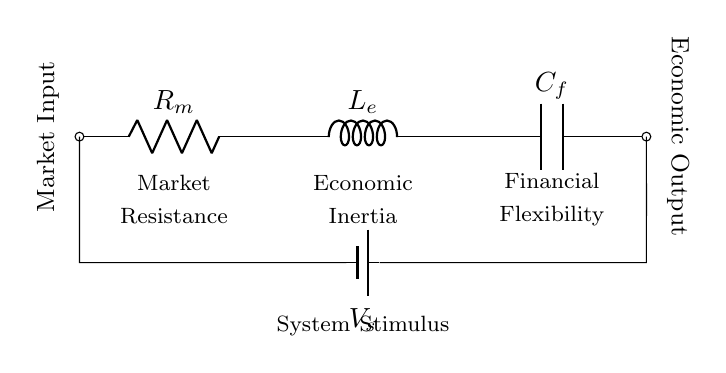What are the components in this circuit? The circuit consists of a resistor, an inductor, and a capacitor. All components are connected in series between the voltage source and the economic output.
Answer: Resistor, Inductor, Capacitor What is the role of the inductor in this circuit? The inductor represents economic inertia, which stores energy in a magnetic field when current flows through it, affecting the circuit's response to changes over time.
Answer: Economic Inertia What does the battery represent in this circuit? The battery is labeled as the voltage source, representing the system stimulus or the external market conditions influencing the circuit's behavior.
Answer: System Stimulus How are the components connected? The components of resistor, inductor, and capacitor are connected in series, meaning that the current flows through each component one after the other.
Answer: In series What does the capacitor signify in this circuit? The capacitor represents financial flexibility, as it can store and release electrical energy, similar to how financial reserves can be utilized in an economy.
Answer: Financial Flexibility Why is there a market input label in the circuit? The market input label indicates the starting point or stimulus of the circuit, signifying the external influences or market conditions affecting the overall economic response.
Answer: Market Input What is the economic output of this circuit? The economic output is indicated at the end of the circuit, representing the result of the circuit's behavior in response to the market input and system stimulus.
Answer: Economic Output 